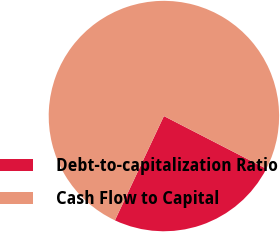Convert chart. <chart><loc_0><loc_0><loc_500><loc_500><pie_chart><fcel>Debt-to-capitalization Ratio<fcel>Cash Flow to Capital<nl><fcel>24.43%<fcel>75.57%<nl></chart> 